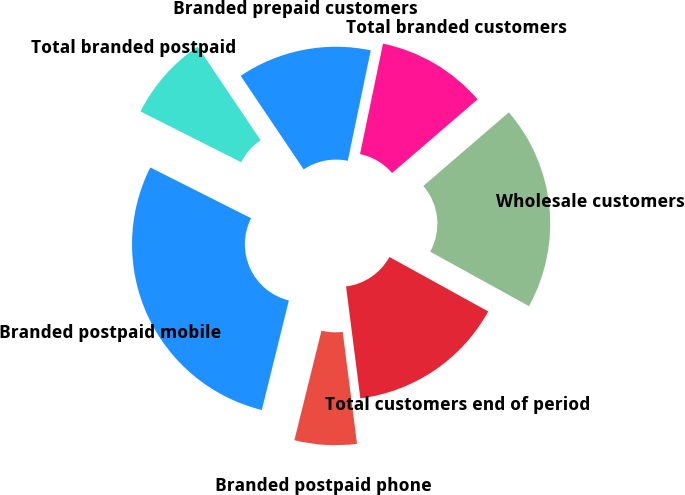Convert chart to OTSL. <chart><loc_0><loc_0><loc_500><loc_500><pie_chart><fcel>Branded postpaid phone<fcel>Branded postpaid mobile<fcel>Total branded postpaid<fcel>Branded prepaid customers<fcel>Total branded customers<fcel>Wholesale customers<fcel>Total customers end of period<nl><fcel>5.88%<fcel>28.57%<fcel>8.15%<fcel>12.69%<fcel>10.42%<fcel>19.33%<fcel>14.96%<nl></chart> 